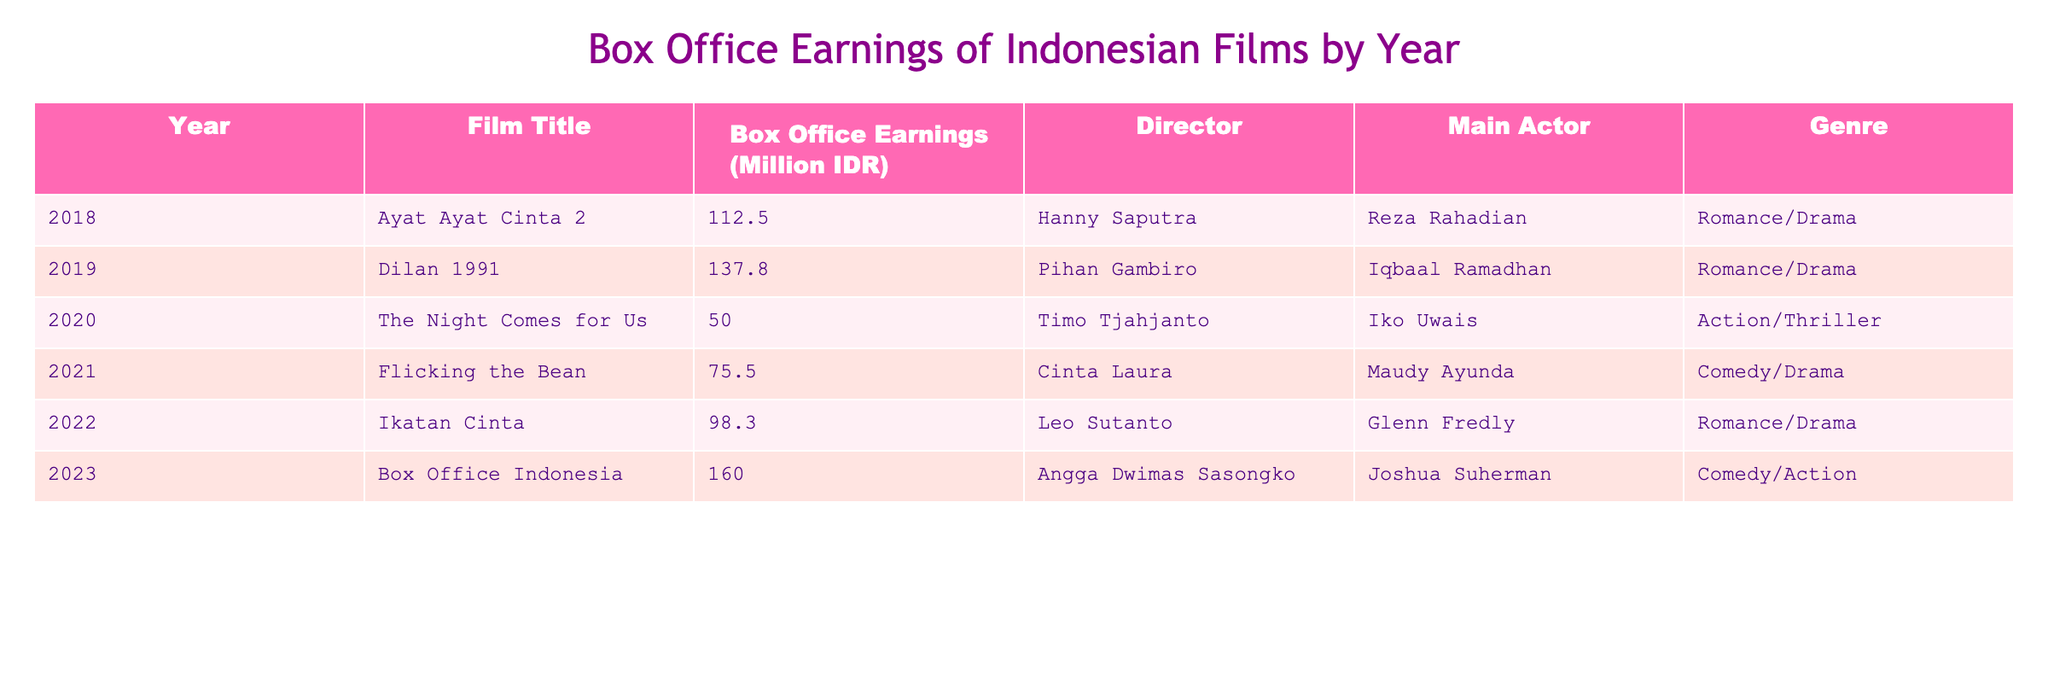What was the highest box office earning in the table? The table lists the box office earnings for different films, and the highest value can be found by scanning through the earnings column. The highest earning is 160.0 million IDR from the film 'Box Office Indonesia' in 2023.
Answer: 160.0 million IDR Which film had the lowest earnings? The film with the lowest earnings can be identified by looking for the smallest value in the box office earnings column. The lowest earning is 50.0 million IDR from the film 'The Night Comes for Us' in 2020.
Answer: 50.0 million IDR How many films had earnings over 100 million IDR? By counting the films with box office earnings greater than 100 million IDR, we find that there are four films: 'Ayat Ayat Cinta 2', 'Dilan 1991', 'Ikatan Cinta', and 'Box Office Indonesia'.
Answer: 4 What is the average box office earning of the films listed? To calculate the average earnings, we sum the box office earnings (112.5 + 137.8 + 50.0 + 75.5 + 98.3 + 160.0 = 634.1 million IDR) and divide by the number of films (6). Thus, the average is 634.1 / 6 = 105.68 million IDR.
Answer: 105.68 million IDR Is 'Flicking the Bean' the only comedy film listed? By checking the genre of all films in the table, we find that 'Flicking the Bean' is a comedy/drama, and 'Box Office Indonesia' is a comedy/action. Thus, 'Flicking the Bean' is not the only comedy film listed.
Answer: No Which director had films with the highest combined box office earnings? By grouping the films by director and summing their respective earnings, we find that Angga Dwimas Sasongko (with 'Box Office Indonesia') has the highest single earning, but no other films to sum with it. Thus, this question doesn't lead to a combined total above others already noted. Nonetheless, Hanny Saputra (with 'Ayat Ayat Cinta 2') and Pihan Gambiro (with 'Dilan 1991') have noteworthy individual totals too.
Answer: No clear highest combined due to single film per director 